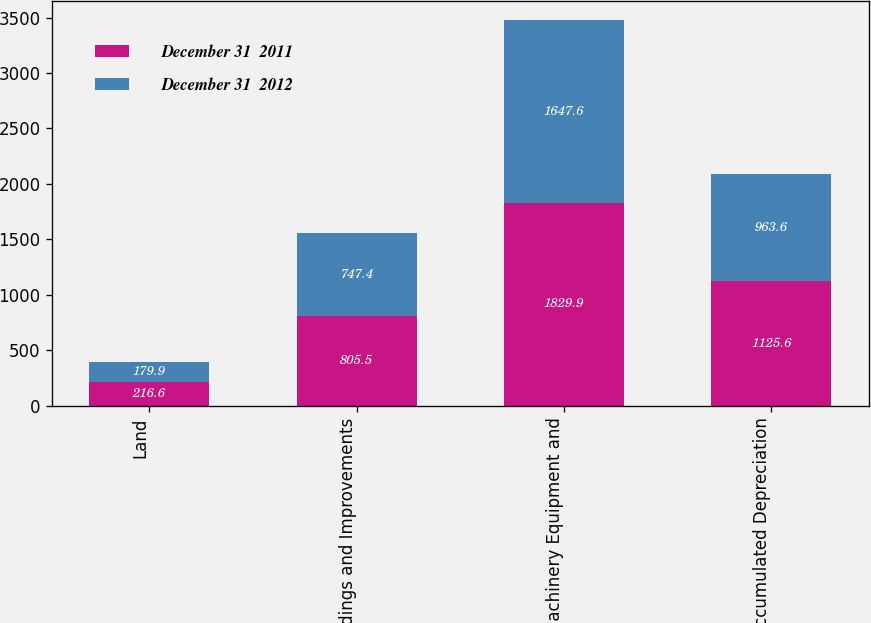<chart> <loc_0><loc_0><loc_500><loc_500><stacked_bar_chart><ecel><fcel>Land<fcel>Buildings and Improvements<fcel>Machinery Equipment and<fcel>Less Accumulated Depreciation<nl><fcel>December 31  2011<fcel>216.6<fcel>805.5<fcel>1829.9<fcel>1125.6<nl><fcel>December 31  2012<fcel>179.9<fcel>747.4<fcel>1647.6<fcel>963.6<nl></chart> 